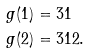Convert formula to latex. <formula><loc_0><loc_0><loc_500><loc_500>g ( \tt { 1 } ) & = \tt { 3 1 } \\ g ( \tt { 2 } ) & = \tt { 3 1 2 } .</formula> 